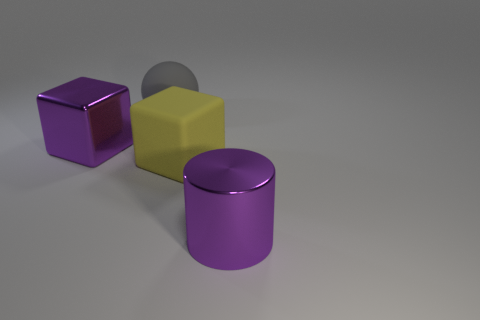Are there an equal number of big rubber blocks to the right of the big yellow thing and big purple metallic blocks left of the purple cube? Upon examining the image, I can confirm that there is one large purple rubber block to the right of the big yellow object. To the left of the purple cube, there is also one big purple metallic cylinder. So, yes, there is an equal number: one of each kind, positioned as specified in your question. 